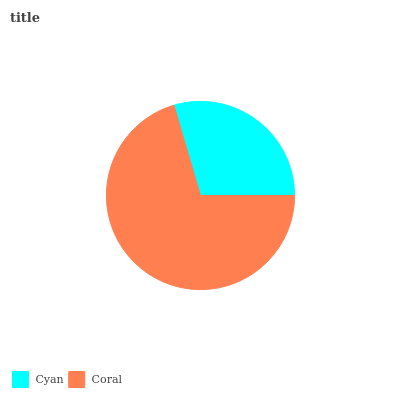Is Cyan the minimum?
Answer yes or no. Yes. Is Coral the maximum?
Answer yes or no. Yes. Is Coral the minimum?
Answer yes or no. No. Is Coral greater than Cyan?
Answer yes or no. Yes. Is Cyan less than Coral?
Answer yes or no. Yes. Is Cyan greater than Coral?
Answer yes or no. No. Is Coral less than Cyan?
Answer yes or no. No. Is Coral the high median?
Answer yes or no. Yes. Is Cyan the low median?
Answer yes or no. Yes. Is Cyan the high median?
Answer yes or no. No. Is Coral the low median?
Answer yes or no. No. 